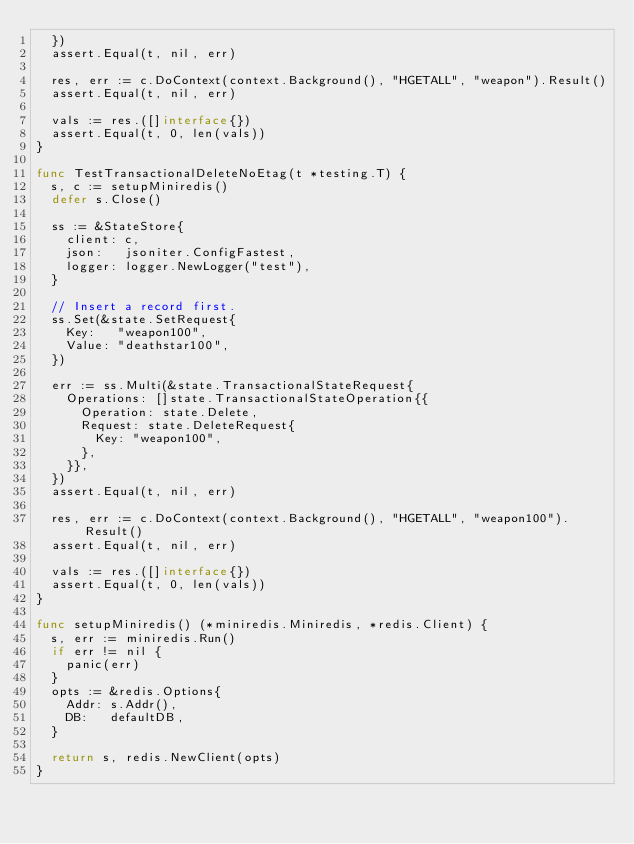Convert code to text. <code><loc_0><loc_0><loc_500><loc_500><_Go_>	})
	assert.Equal(t, nil, err)

	res, err := c.DoContext(context.Background(), "HGETALL", "weapon").Result()
	assert.Equal(t, nil, err)

	vals := res.([]interface{})
	assert.Equal(t, 0, len(vals))
}

func TestTransactionalDeleteNoEtag(t *testing.T) {
	s, c := setupMiniredis()
	defer s.Close()

	ss := &StateStore{
		client: c,
		json:   jsoniter.ConfigFastest,
		logger: logger.NewLogger("test"),
	}

	// Insert a record first.
	ss.Set(&state.SetRequest{
		Key:   "weapon100",
		Value: "deathstar100",
	})

	err := ss.Multi(&state.TransactionalStateRequest{
		Operations: []state.TransactionalStateOperation{{
			Operation: state.Delete,
			Request: state.DeleteRequest{
				Key: "weapon100",
			},
		}},
	})
	assert.Equal(t, nil, err)

	res, err := c.DoContext(context.Background(), "HGETALL", "weapon100").Result()
	assert.Equal(t, nil, err)

	vals := res.([]interface{})
	assert.Equal(t, 0, len(vals))
}

func setupMiniredis() (*miniredis.Miniredis, *redis.Client) {
	s, err := miniredis.Run()
	if err != nil {
		panic(err)
	}
	opts := &redis.Options{
		Addr: s.Addr(),
		DB:   defaultDB,
	}

	return s, redis.NewClient(opts)
}
</code> 